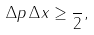<formula> <loc_0><loc_0><loc_500><loc_500>\Delta p \, \Delta x \geq \frac { } { 2 } ,</formula> 